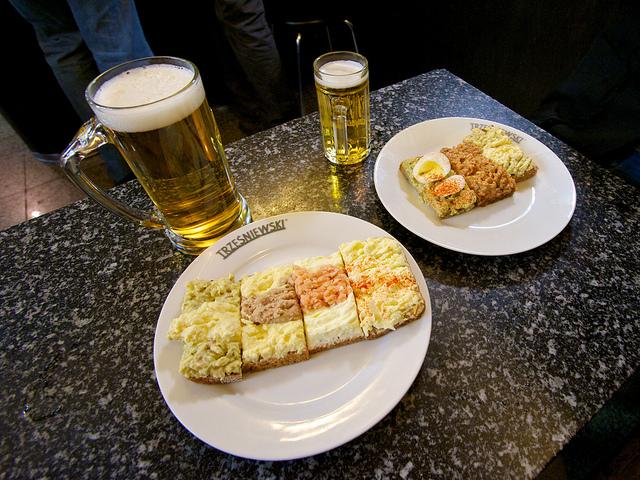Is all of this food vegan?
Short answer required. No. Is the beer on the left the same volume as the one on the right?
Quick response, please. No. Is there a geometric consistency to some of these items?
Write a very short answer. Yes. 